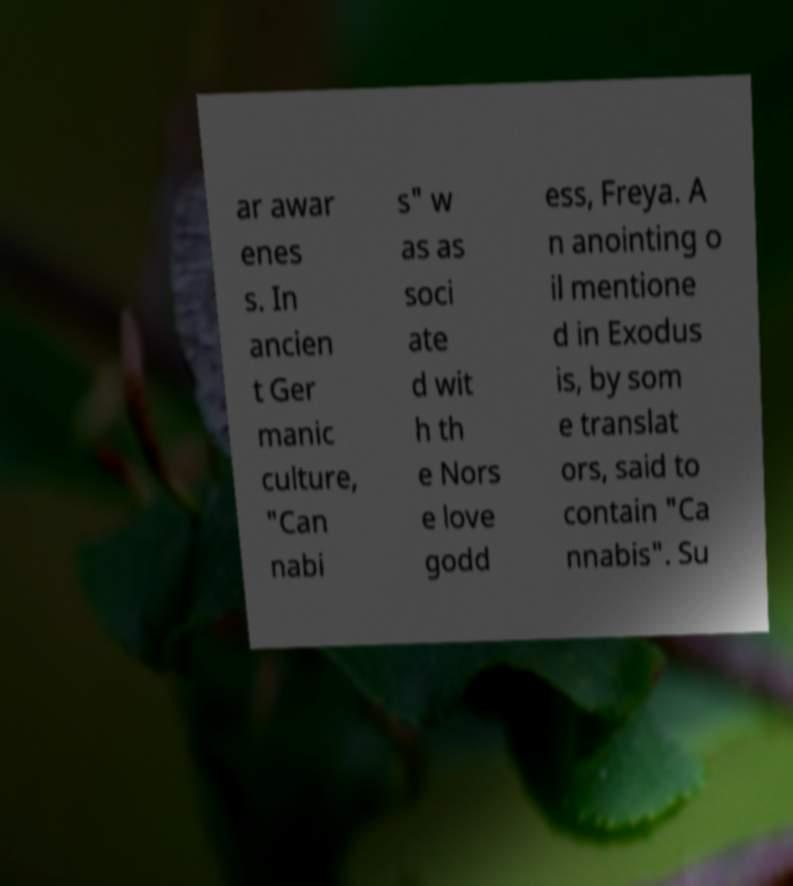Please identify and transcribe the text found in this image. ar awar enes s. In ancien t Ger manic culture, "Can nabi s" w as as soci ate d wit h th e Nors e love godd ess, Freya. A n anointing o il mentione d in Exodus is, by som e translat ors, said to contain "Ca nnabis". Su 